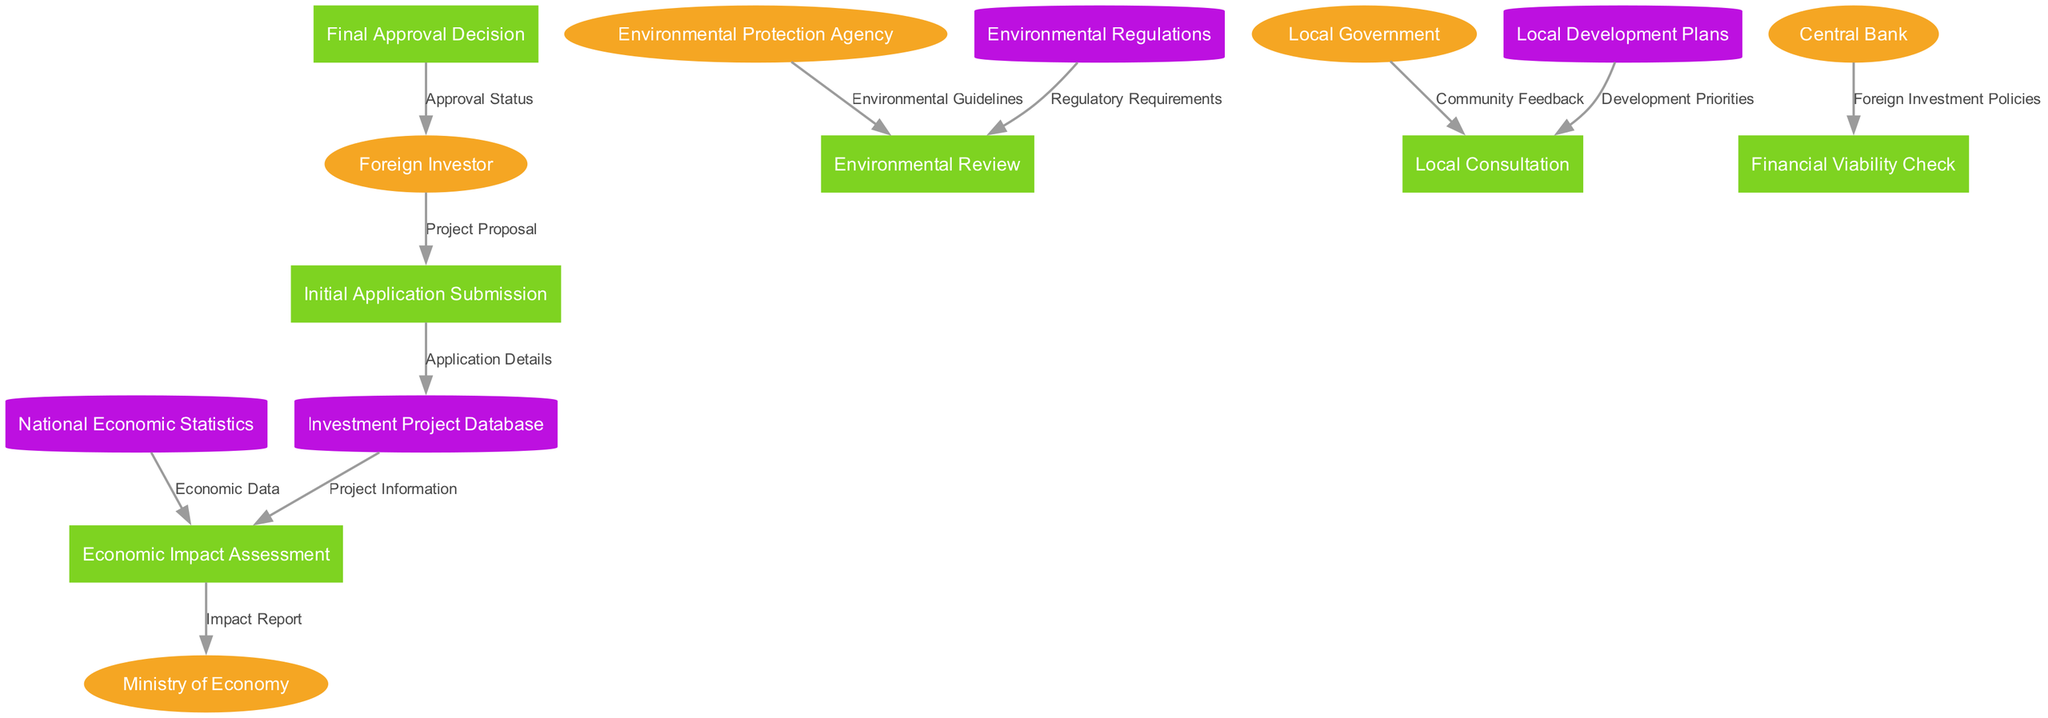What are the external entities involved in the process? The diagram lists five external entities: Foreign Investor, Ministry of Economy, Environmental Protection Agency, Local Government, and Central Bank. These are represented as ellipse-shaped nodes at the beginning of the process.
Answer: Foreign Investor, Ministry of Economy, Environmental Protection Agency, Local Government, Central Bank How many processes are defined in the diagram? The diagram contains six processes that are represented as rectangle-shaped nodes, numbered as they appear: Initial Application Submission, Economic Impact Assessment, Environmental Review, Local Consultation, Financial Viability Check, and Final Approval Decision.
Answer: 6 What data flows from the Environmental Protection Agency to the Environmental Review? The data flow from the Environmental Protection Agency to the Environmental Review is the Environmental Guidelines. This flow is depicted with an arrow connecting the two nodes.
Answer: Environmental Guidelines Which process receives the Approval Status? The Approval Status is received by the Foreign Investor from the Final Approval Decision. This is the last step in the diagram, indicating closure of the approval process.
Answer: Foreign Investor What does the Initial Application Submission provide to the Investment Project Database? The Initial Application Submission provides Application Details to the Investment Project Database as indicated by the flow of data represented in the diagram.
Answer: Application Details Which data stores are referenced in the Economic Impact Assessment? The Economic Impact Assessment references two data stores: the Investment Project Database for Project Information and the National Economic Statistics for Economic Data. Both data flows are essential inputs for the assessment process.
Answer: Investment Project Database, National Economic Statistics How many types of nodes are there in the diagram? There are three types of nodes in the diagram: external entities (5), processes (6), and data stores (4). The distinction between these types is important for understanding the overall flow and structure of the diagram.
Answer: 3 What is the last process before the Approval Status is communicated? The last process before the Approval Status is communicated is the Final Approval Decision. This process involves concluding the assessment of all previous steps before relaying the status to the Foreign Investor.
Answer: Final Approval Decision Which process is directly after the Environmental Review? The process that follows the Environmental Review is the Local Consultation. This flow indicates that after assessing environmental compliance, community feedback is sought to ensure local alignment.
Answer: Local Consultation 